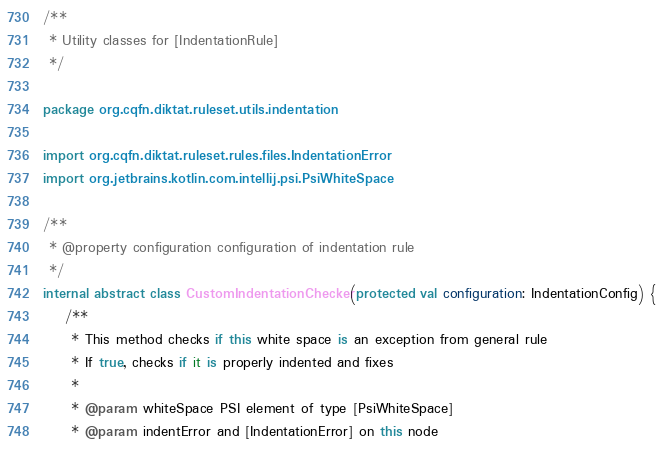<code> <loc_0><loc_0><loc_500><loc_500><_Kotlin_>/**
 * Utility classes for [IndentationRule]
 */

package org.cqfn.diktat.ruleset.utils.indentation

import org.cqfn.diktat.ruleset.rules.files.IndentationError
import org.jetbrains.kotlin.com.intellij.psi.PsiWhiteSpace

/**
 * @property configuration configuration of indentation rule
 */
internal abstract class CustomIndentationChecker(protected val configuration: IndentationConfig) {
    /**
     * This method checks if this white space is an exception from general rule
     * If true, checks if it is properly indented and fixes
     *
     * @param whiteSpace PSI element of type [PsiWhiteSpace]
     * @param indentError and [IndentationError] on this node</code> 